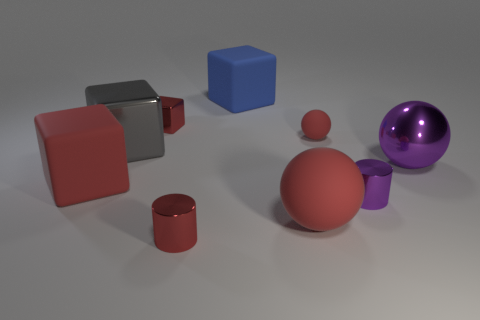How does the lighting affect the appearance of the objects? The lighting in the image casts soft shadows and gives the objects a slight gloss, enhancing the perception of their three-dimensional shapes. It also emphasizes the textures and reflective properties of the materials, such as the metallic sheen on some objects and the matte appearance of others. Does the lighting source seem to be coming from a specific direction? Yes, the lighting appears to be coming from the upper left side of the image, as indicated by the orientation and lengths of the shadows cast by the objects on the right. 